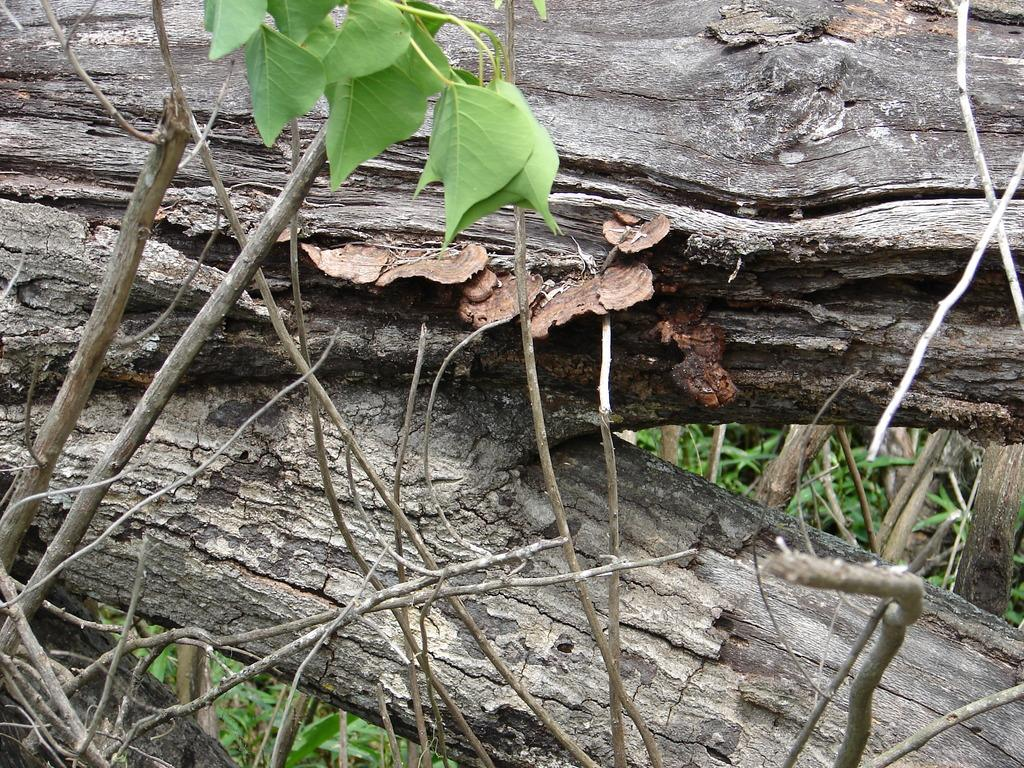What type of material is present in the image? There is a wood in the image. Can you describe the object at the top of the image? A leaf is visible at the top of the image. What type of vegetation can be seen in the background of the image? There are grasses in the background of the image. What year is depicted on the wood in the image? There is no year visible on the wood in the image. What type of sweater is being worn by the wood in the image? The wood in the image is not a person or an entity that can wear a sweater. 